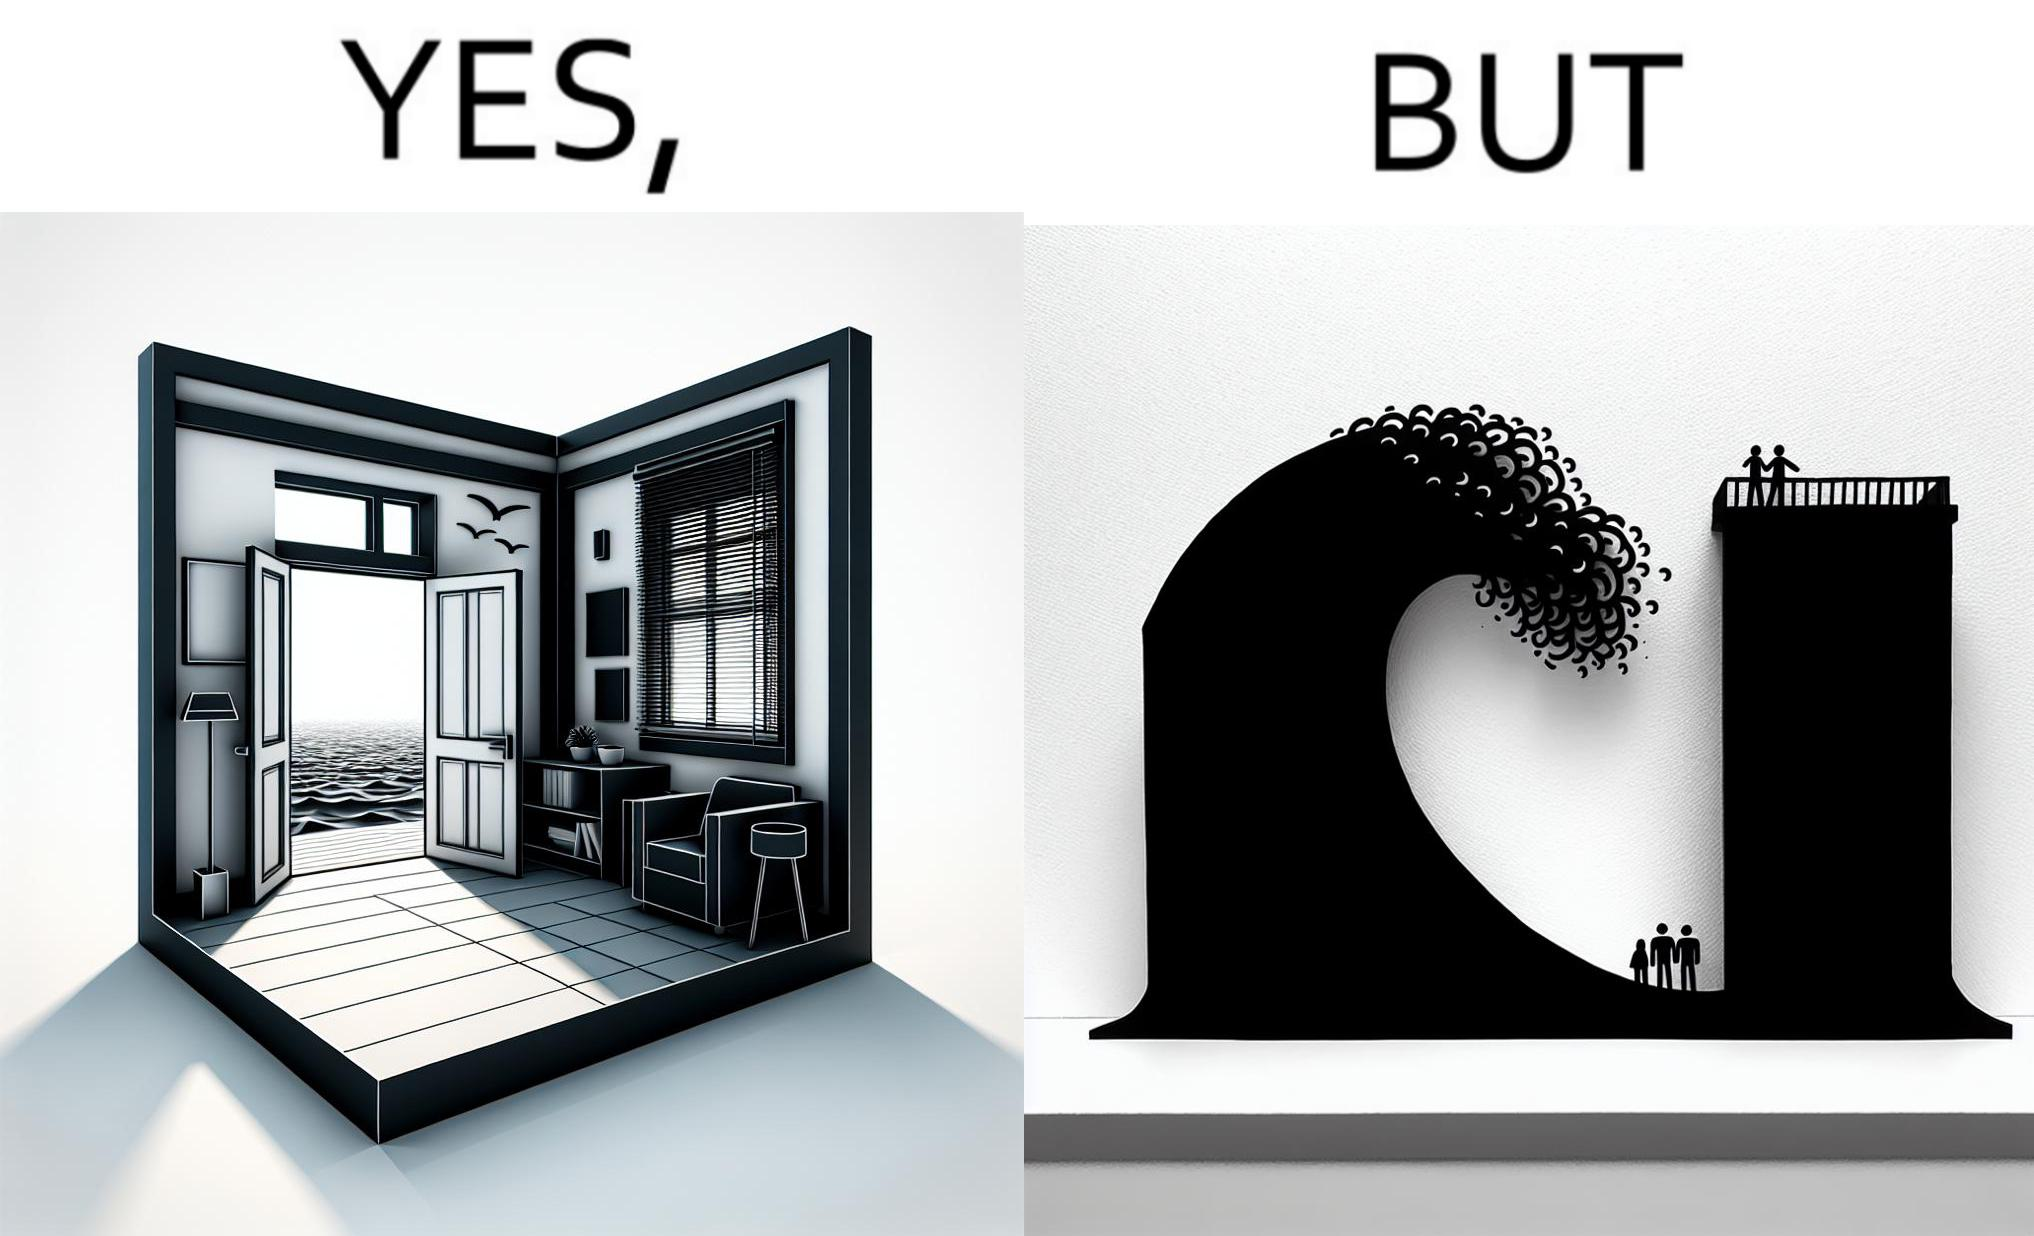Describe what you see in the left and right parts of this image. In the left part of the image: a room with a sea-facing door In the right part of the image: high waves in the sea twice of the height of the building near the sea 